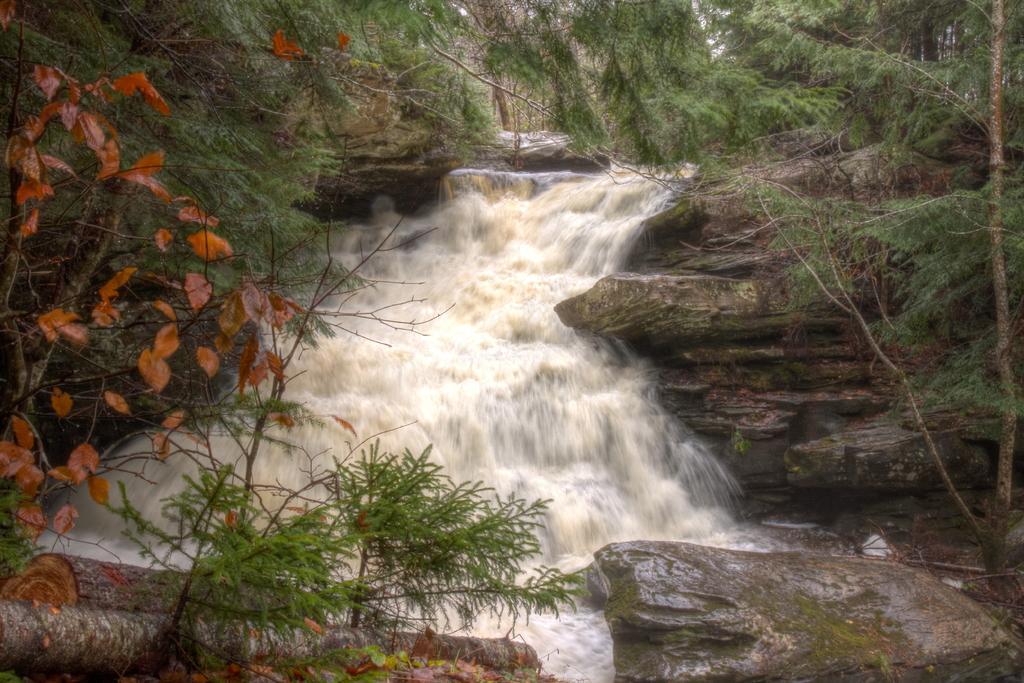Please provide a concise description of this image. In this picture there is water and there are few rocks and trees on either sides of it. 